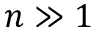<formula> <loc_0><loc_0><loc_500><loc_500>n \gg 1</formula> 